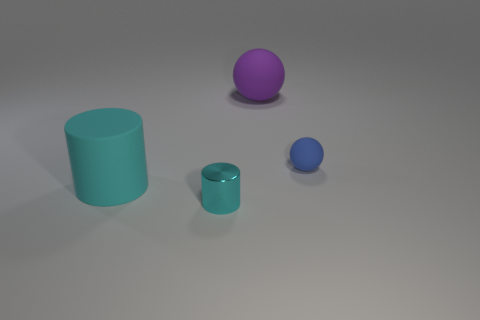The blue thing that is made of the same material as the large purple thing is what size?
Offer a very short reply. Small. The large rubber cylinder has what color?
Offer a very short reply. Cyan. What number of small metal objects are the same color as the rubber cylinder?
Provide a short and direct response. 1. There is a blue sphere that is the same size as the metal thing; what material is it?
Keep it short and to the point. Rubber. Are there any tiny blue balls to the right of the large rubber object left of the large purple matte thing?
Your answer should be very brief. Yes. How many other things are there of the same color as the tiny shiny cylinder?
Offer a terse response. 1. How big is the cyan shiny object?
Your response must be concise. Small. Are there any large red rubber cubes?
Your answer should be very brief. No. Are there more big objects that are behind the big cyan rubber cylinder than big purple rubber objects in front of the purple matte ball?
Make the answer very short. Yes. What material is the object that is on the left side of the small blue matte object and behind the big cyan rubber object?
Provide a short and direct response. Rubber. 